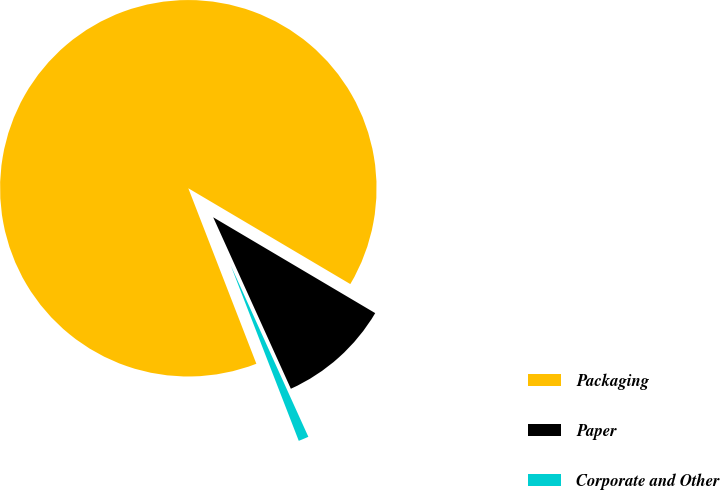Convert chart. <chart><loc_0><loc_0><loc_500><loc_500><pie_chart><fcel>Packaging<fcel>Paper<fcel>Corporate and Other<nl><fcel>89.38%<fcel>9.73%<fcel>0.88%<nl></chart> 